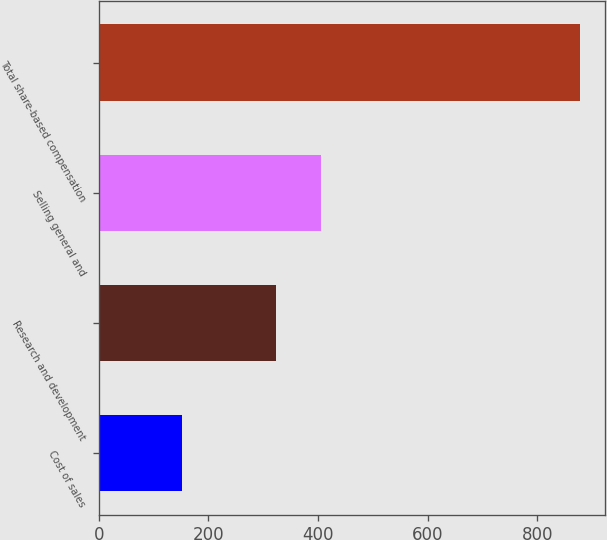Convert chart to OTSL. <chart><loc_0><loc_0><loc_500><loc_500><bar_chart><fcel>Cost of sales<fcel>Research and development<fcel>Selling general and<fcel>Total share-based compensation<nl><fcel>151<fcel>323<fcel>405<fcel>879<nl></chart> 